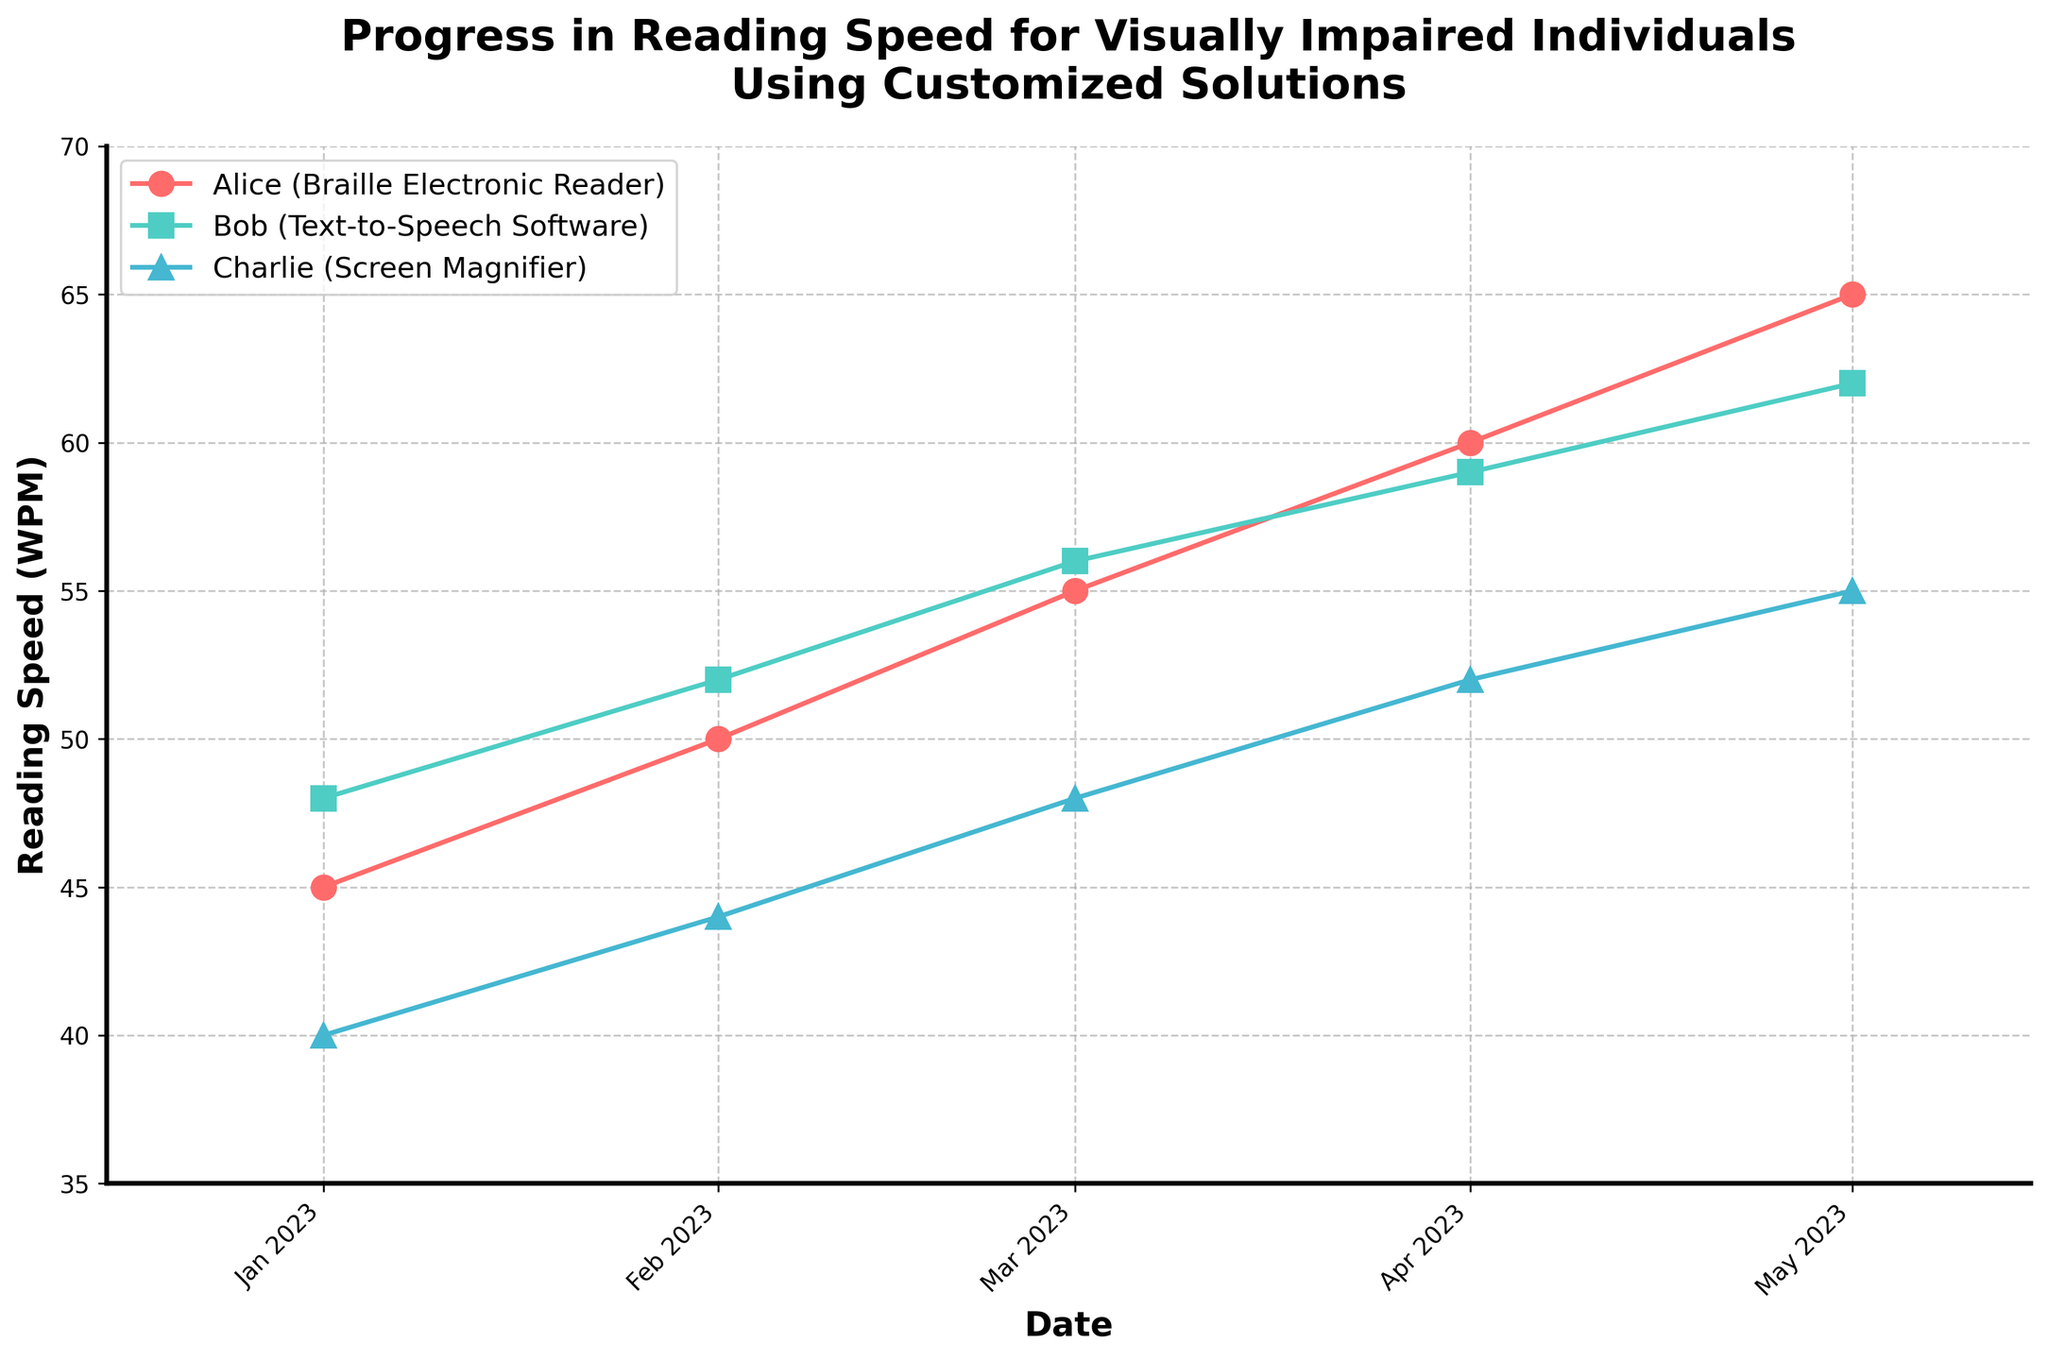What is the title of the figure? The title is located at the top of the figure and describes what the figure is about.
Answer: Progress in Reading Speed for Visually Impaired Individuals Using Customized Solutions Which participant had the highest reading speed in May 2023? Look at the plot for May 2023 and identify the participant with the highest reading speed.
Answer: Alice How many different types of customized solutions are represented in the figure? Count the distinct types of solutions listed in the legend.
Answer: Three What is the date range covered in the figure? Examine the x-axis which shows the dates ranging from the beginning to the end of the plot.
Answer: January 2023 to May 2023 Which participant showed the greatest increase in reading speed from January to May 2023? For each participant, calculate the difference in reading speed between January and May. The participant with the largest difference is the answer.
Answer: Alice Compare Alice’s reading speed in January and March 2023. Which month had a higher reading speed and by how much? Check Alice’s reading speeds for January and March on the plot, and compute the difference.
Answer: March, by 10 WPM Is the trend in reading speed over time for Charlie increasing, decreasing, or stable? Observe Charlie's reading speed at all data points and determine the overall trend.
Answer: Increasing What is the average reading speed for Bob over the five months? Sum Bob’s reading speeds for each month and divide by the number of months (5). The values are: 48, 52, 56, 59, 62. (48 + 52 + 56 + 59 + 62) / 5 = 277 / 5 = 55.4
Answer: 55.4 WPM Which month shows the most improvement in reading speed for any participant, and who is that participant? Calculate the month-to-month improvements for each participant and identify the largest single month’s increase.
Answer: January to February, Alice Does any participant have the same reading speed for two different months? Examine each participant’s reading speed across all months and check for any repeating values.
Answer: No 